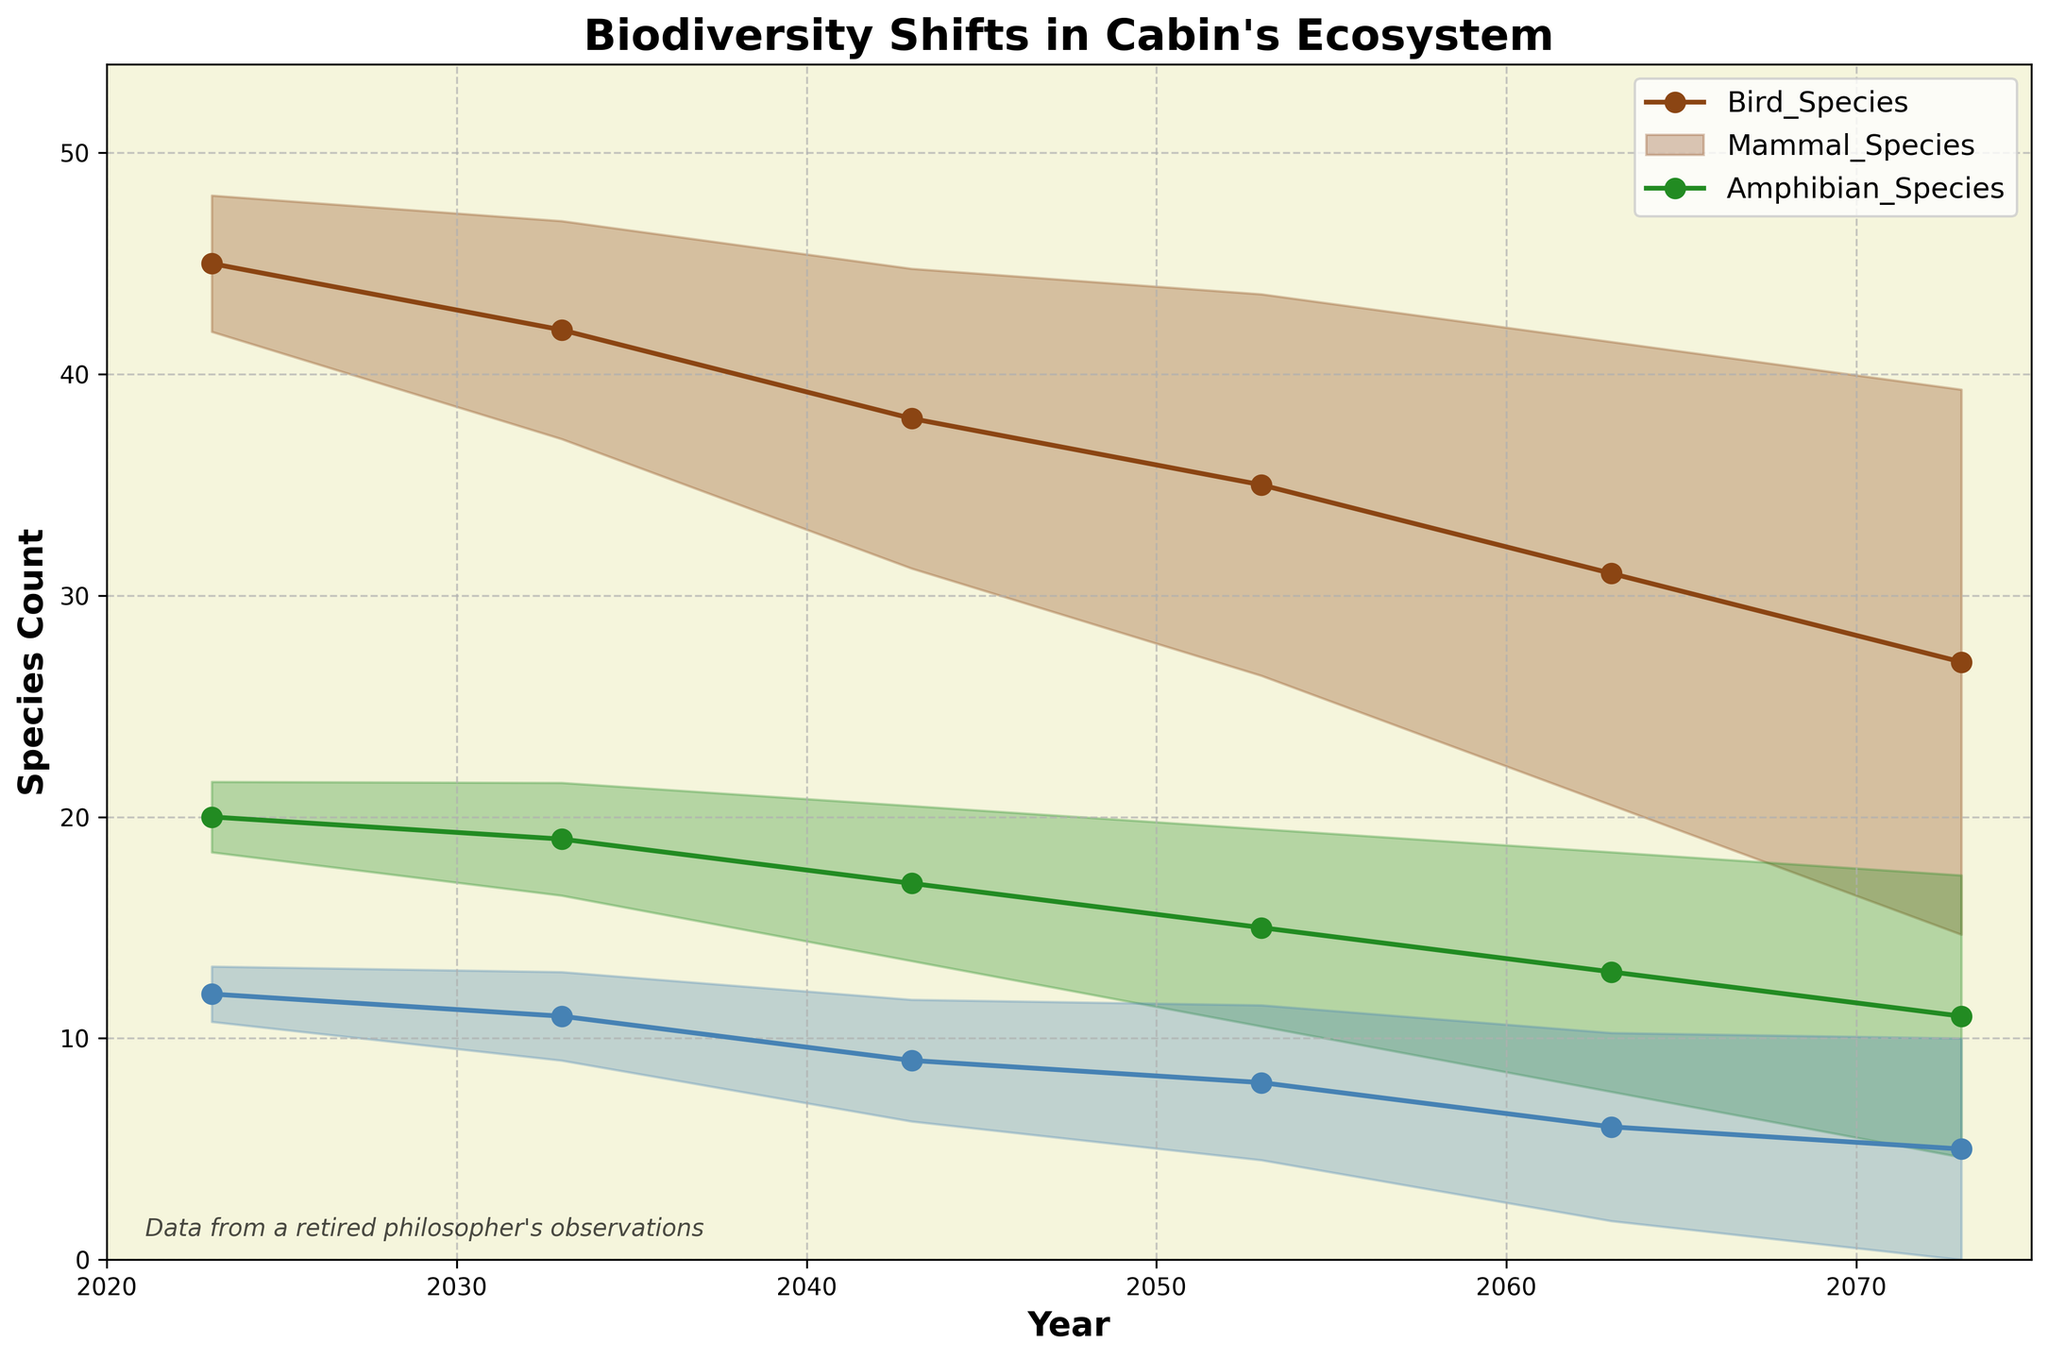What is the title of the figure? The title is usually displayed at the top and provides a summary of the content. The title is "Biodiversity Shifts in Cabin's Ecosystem".
Answer: Biodiversity Shifts in Cabin's Ecosystem How many years are covered in the plot? The years are plotted on the x-axis, starting from 2023 to 2073. Counting all the years, the plot covers 6 years: 2023, 2033, 2043, 2053, 2063, and 2073.
Answer: 6 years Which biodiversity metric shows the highest count in 2023? To find the highest count for biodiversity metrics in the year 2023, compare the values of Bird Species (45), Mammal Species (20), and Amphibian Species (12). The highest count is 45 for Bird Species.
Answer: Bird Species What is the general trend in the number of Mammal Species from 2023 to 2073? Observing the plot line for Mammal Species from 2023 to 2073, we see a decreasing trend. Specifically, it starts at 20 in 2023 and drops to 11 in 2073.
Answer: Decreasing What is the difference in the number of Bird Species between 2023 and 2073? To calculate this difference, subtract the number of Bird Species in 2073 (27) from the number of Bird Species in 2023 (45). The difference is 45 - 27 = 18.
Answer: 18 What is the standard deviation spread range for Bird Species in 2073? The fan chart provides a range indicating uncertainty. The standard deviation spread range is from the lower bound (27 - std_dev) to the upper bound (27 + std_dev). Estimation shows the lower bound around 20 and the upper around 35, giving a range.
Answer: Approximately [20, 35] Which biodiversity metric drops below 10 species first, and in what year? Observing each plotted line, Mammal Species hits 9 around 2063 before Amphibian Species and Bird Species drop below 10.
Answer: Mammal Species, 2063 How much did the number of Amphibian Species decrease from 2023 to 2073? Subtract the number of Amphibian Species in 2073 (5) from the number in 2023 (12). The decrease is 12 - 5 = 7.
Answer: 7 Which metric shows the most variability according to its fan spread? Comparing the widths of the fans around each metric's line, Bird Species have the widest range, showing the most variability.
Answer: Bird Species 